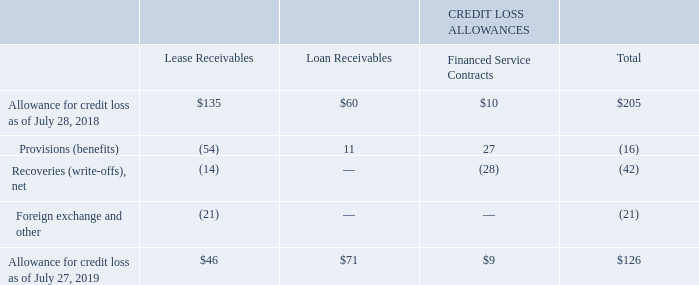(c) Allowance for Credit Loss Rollforward
The allowances for credit loss and the related financing receivables are summarized as follows (in millions):
What was the allowance for credit loss for lease receivables in 2018?
Answer scale should be: million. 135. What were the total provisions (benefits)?
Answer scale should be: million. (16). What were the total Foreign exchange and other?
Answer scale should be: million. (21). What was the difference between total provisions (benefits) and net recoveries (write-offs)?
Answer scale should be: million. -16-(-42)
Answer: 26. What was the allowance for credit loss for financed service contracts as a percentage of total allowance for credit loss in 2018?
Answer scale should be: percent. 10/205
Answer: 4.88. What was the percentage change in the total allowance for credit loss between 2018 and 2019?
Answer scale should be: percent. (126-205)/205
Answer: -38.54. 